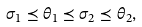Convert formula to latex. <formula><loc_0><loc_0><loc_500><loc_500>\sigma _ { 1 } \preceq \theta _ { 1 } \preceq \sigma _ { 2 } \preceq \theta _ { 2 } ,</formula> 